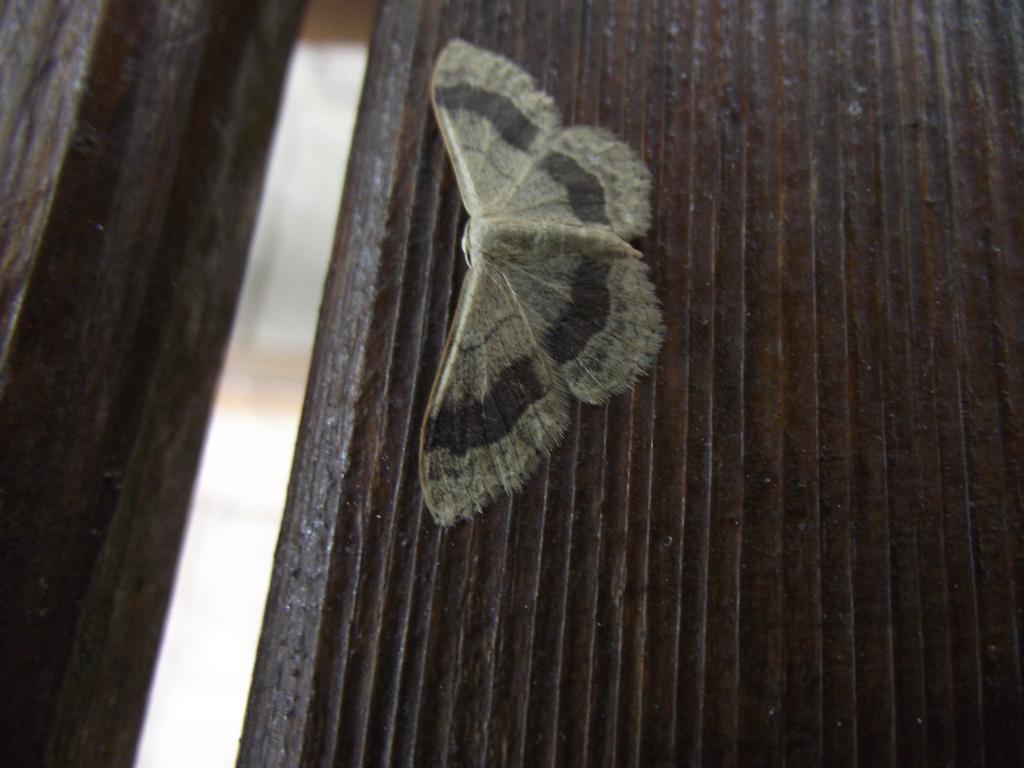In one or two sentences, can you explain what this image depicts? In this image I can see a grey and black colour insect. I can also see black colour in background. 